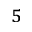Convert formula to latex. <formula><loc_0><loc_0><loc_500><loc_500>^ { 5 }</formula> 